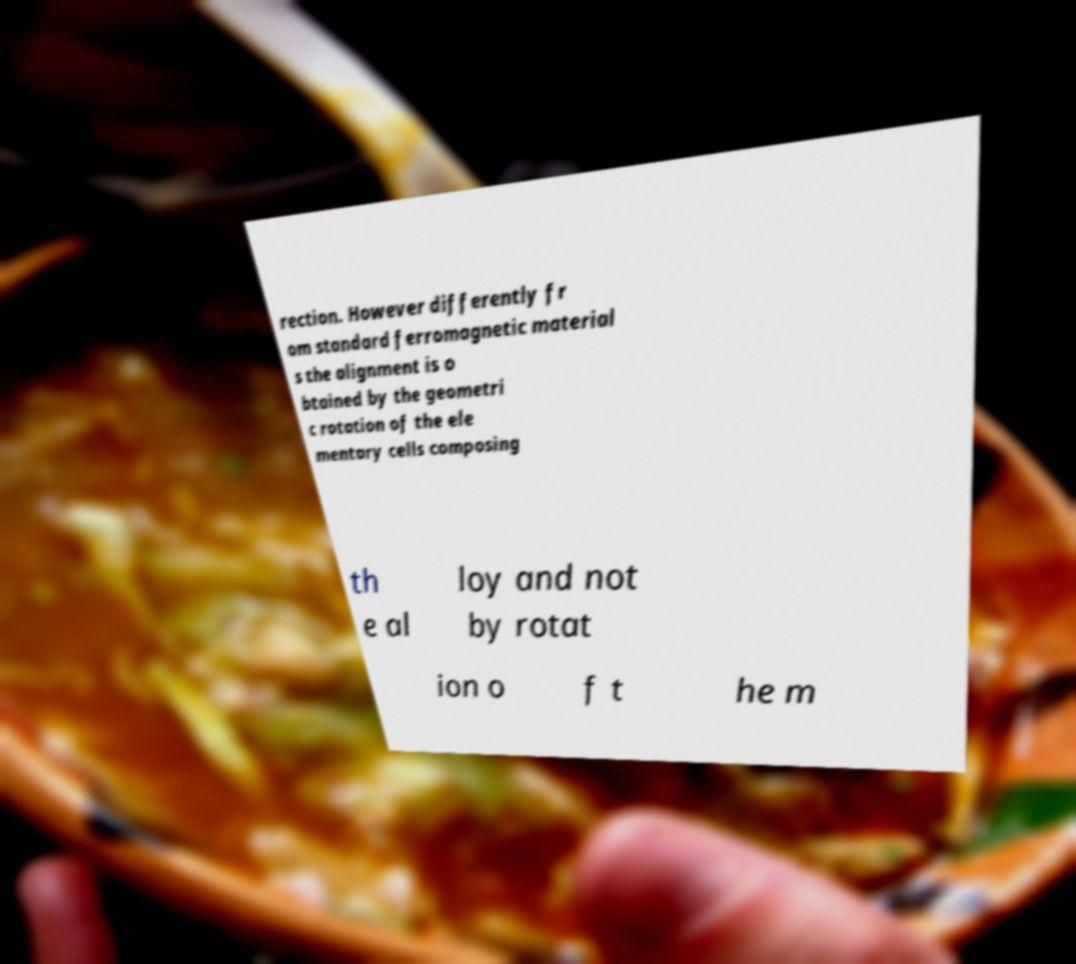There's text embedded in this image that I need extracted. Can you transcribe it verbatim? rection. However differently fr om standard ferromagnetic material s the alignment is o btained by the geometri c rotation of the ele mentary cells composing th e al loy and not by rotat ion o f t he m 